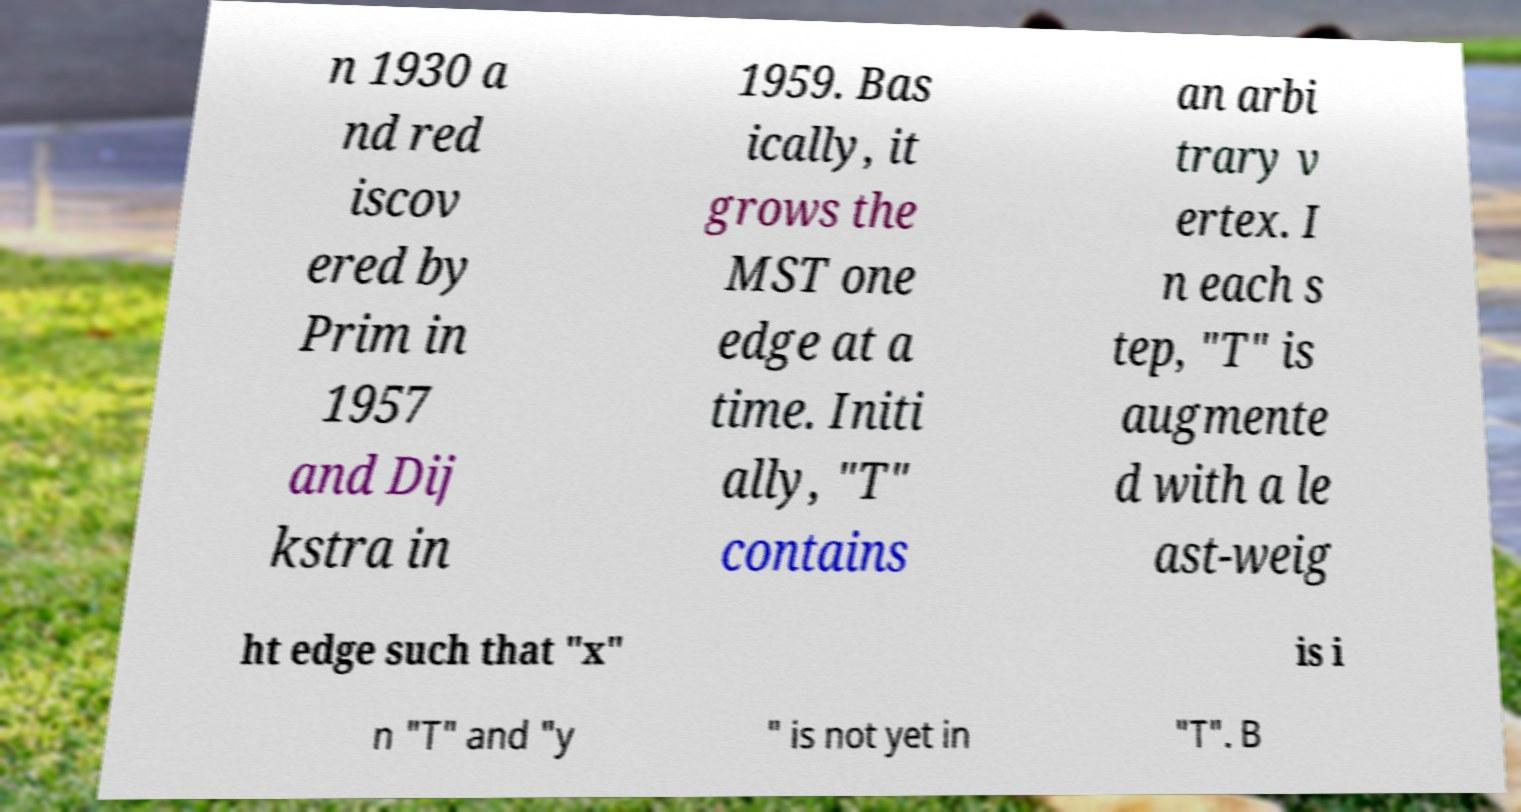Please identify and transcribe the text found in this image. n 1930 a nd red iscov ered by Prim in 1957 and Dij kstra in 1959. Bas ically, it grows the MST one edge at a time. Initi ally, "T" contains an arbi trary v ertex. I n each s tep, "T" is augmente d with a le ast-weig ht edge such that "x" is i n "T" and "y " is not yet in "T". B 